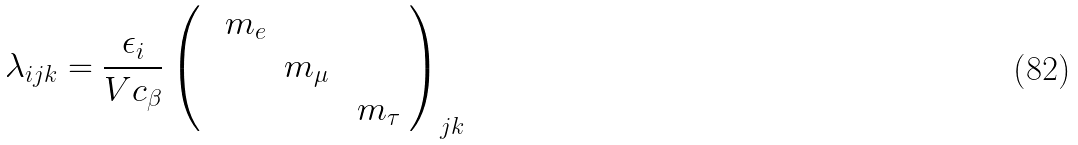<formula> <loc_0><loc_0><loc_500><loc_500>\lambda _ { i j k } = \frac { \epsilon _ { i } } { V c _ { \beta } } \left ( { \ \begin{array} { c c c } \, m _ { e } & \, & \, \\ & m _ { \mu } \, & \, \\ \, & \, & \, m _ { \tau } \end{array} } \right ) _ { j k }</formula> 